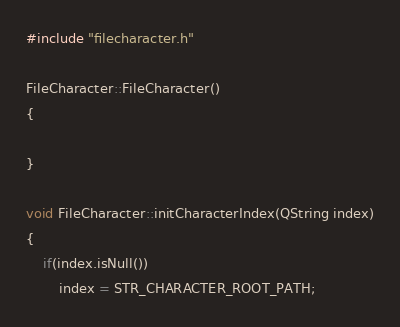<code> <loc_0><loc_0><loc_500><loc_500><_C++_>#include "filecharacter.h"

FileCharacter::FileCharacter()
{

}

void FileCharacter::initCharacterIndex(QString index)
{
    if(index.isNull())
        index = STR_CHARACTER_ROOT_PATH;
</code> 